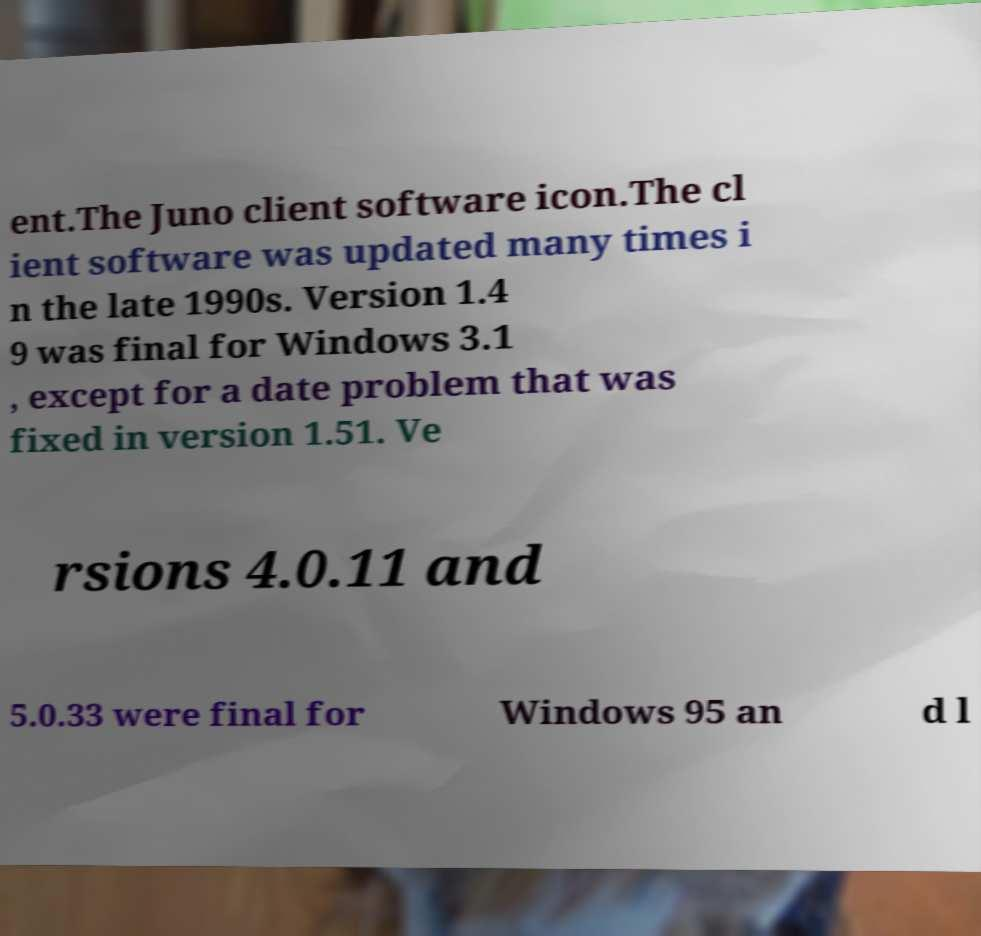For documentation purposes, I need the text within this image transcribed. Could you provide that? ent.The Juno client software icon.The cl ient software was updated many times i n the late 1990s. Version 1.4 9 was final for Windows 3.1 , except for a date problem that was fixed in version 1.51. Ve rsions 4.0.11 and 5.0.33 were final for Windows 95 an d l 